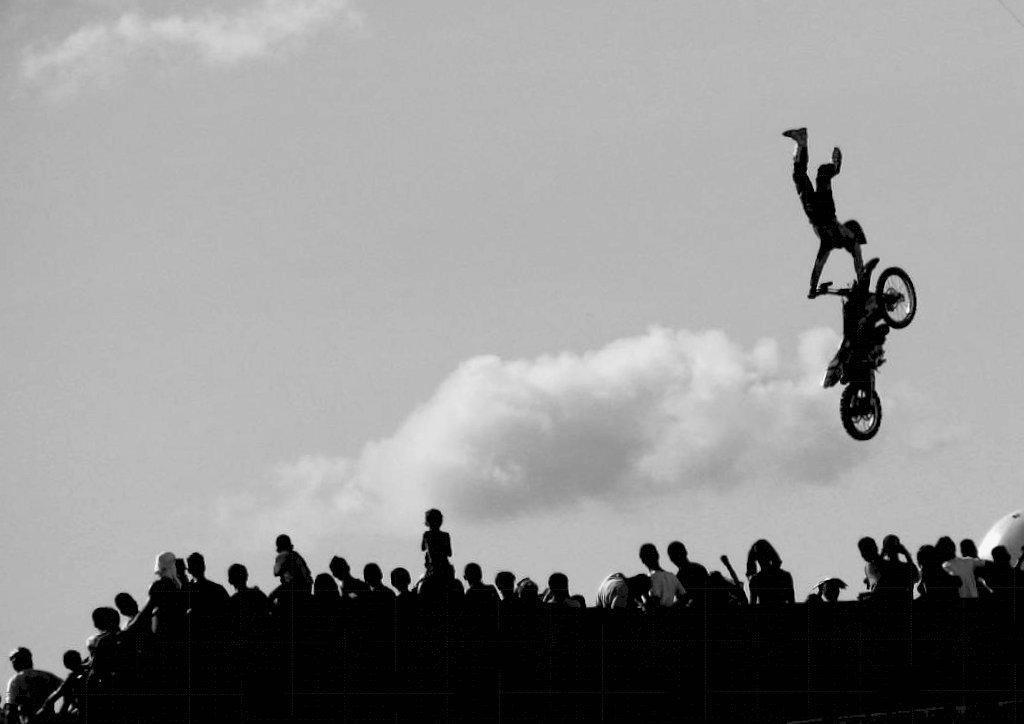What can be seen in the image? There are people standing in the image. Can you describe the man on the right side of the image? The man on the right side of the image is holding a bike. What is visible at the top of the image? The sky is visible at the top of the image. What verse is being recited by the group in the image? There is no group or verse present in the image; it only shows people standing and a man holding a bike. 